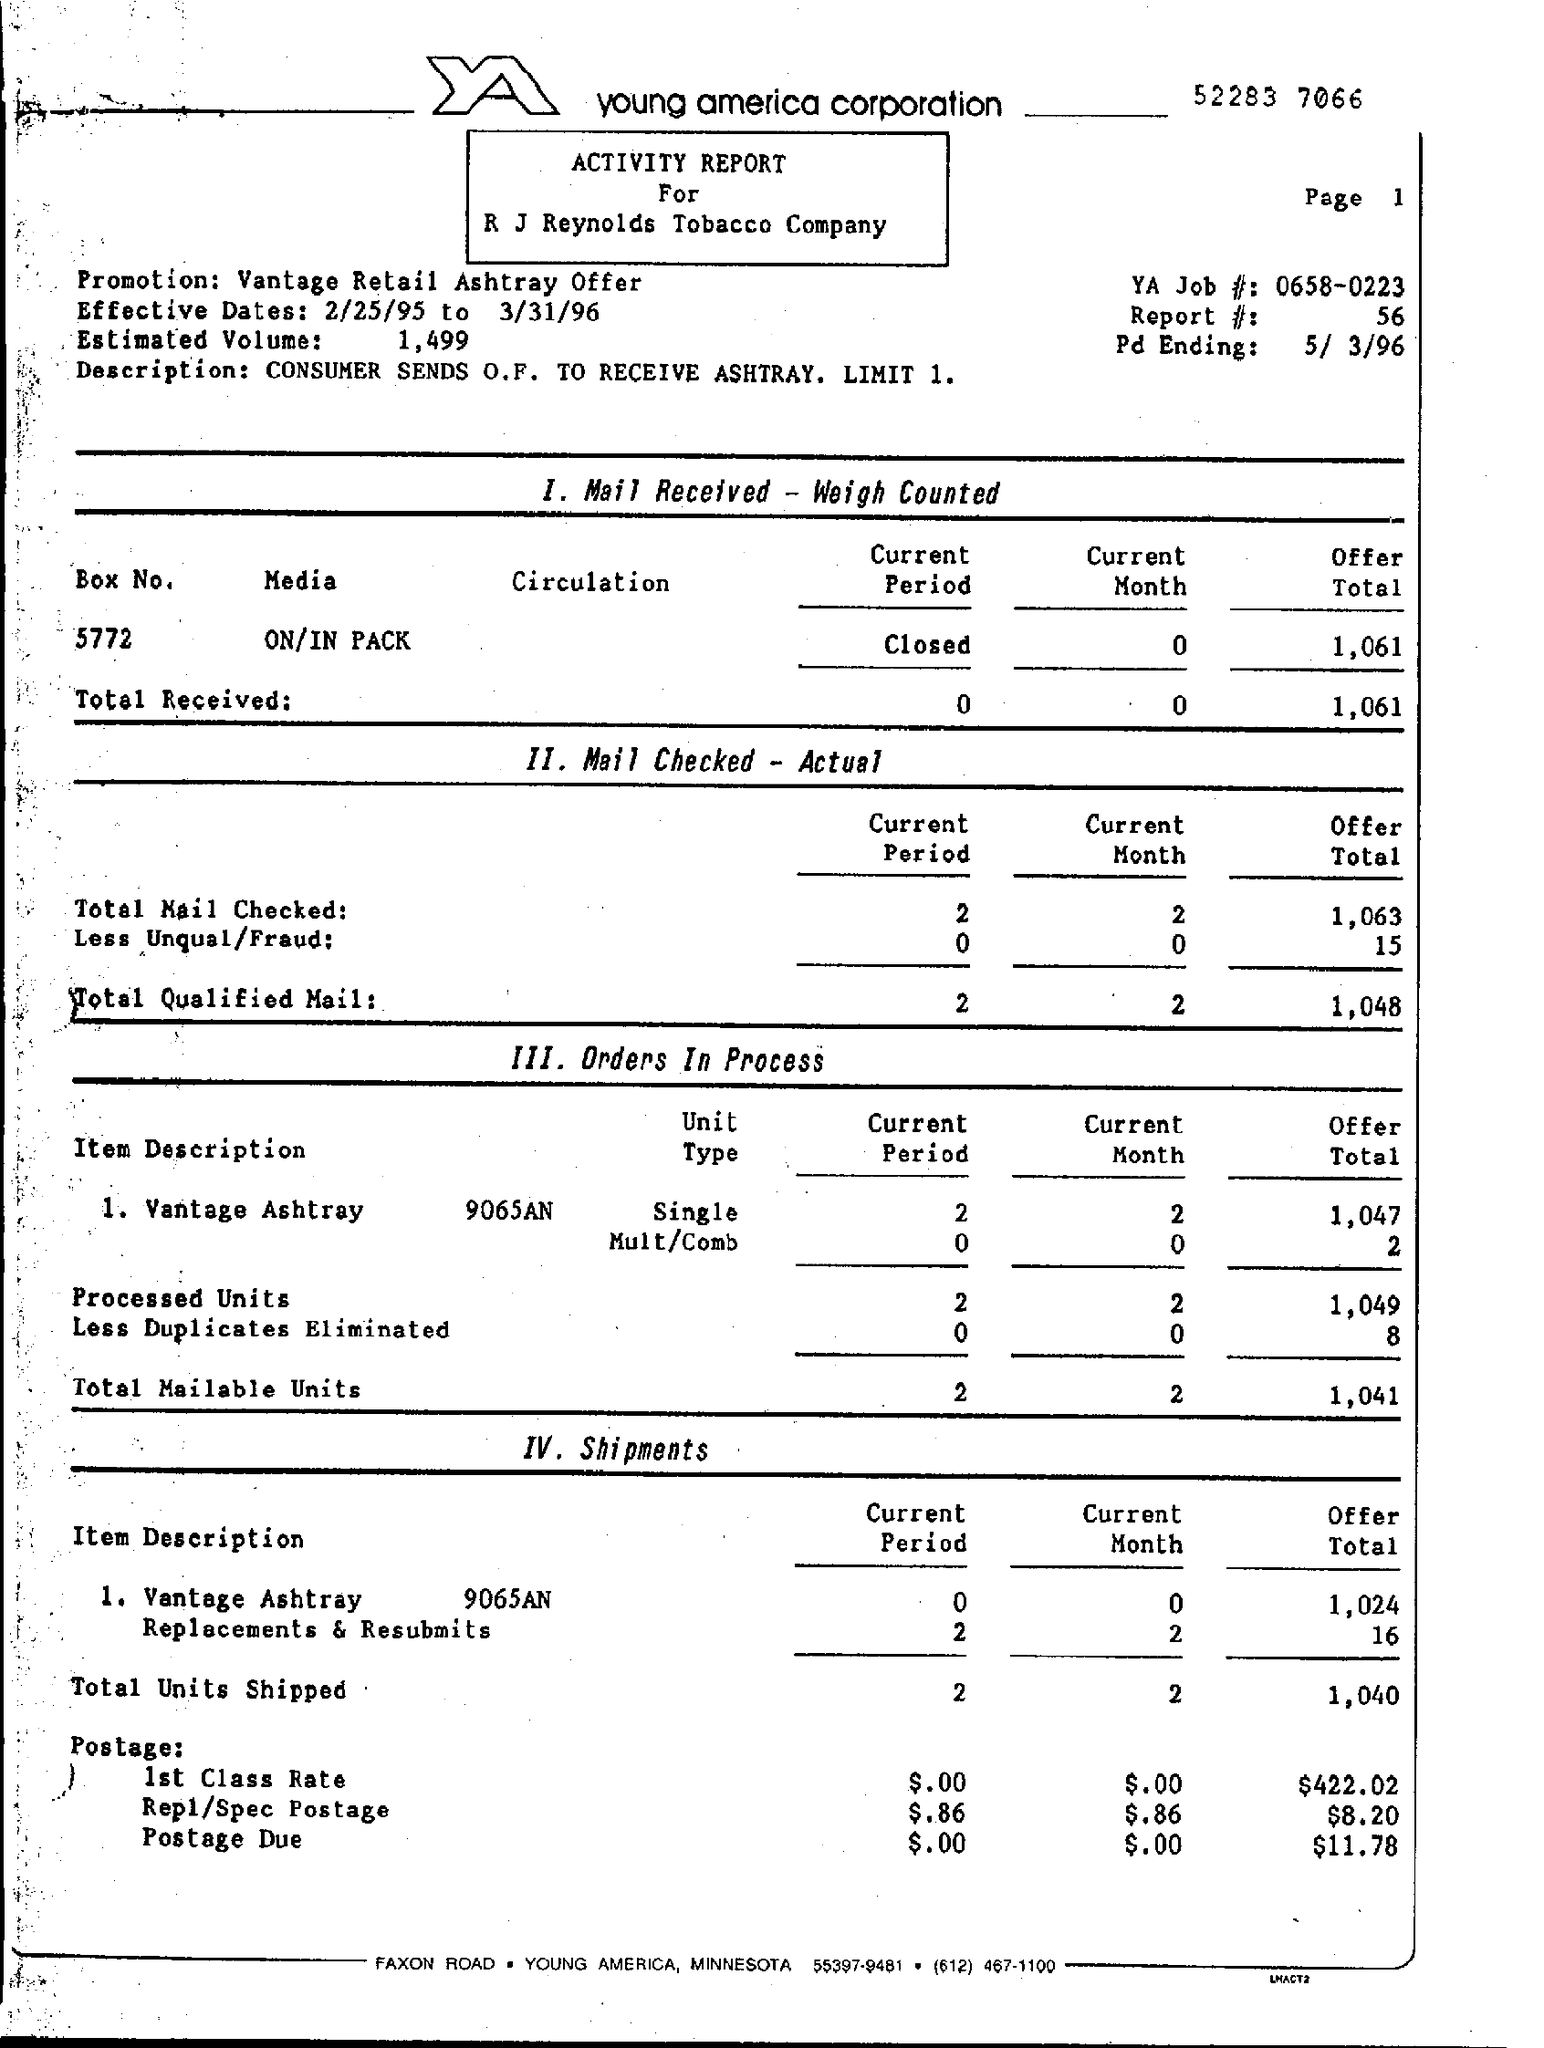Outline some significant characteristics in this image. A consumer sends an order fulfillment (O.F.) to receive an ashtray, limited to one per order. The first stage is when the mail is received and weighed. In the current month, 2 out of the total number of qualified mail messages were checked. The total units shipped in the current period is 2.. The offer in postage due is $11.78. 